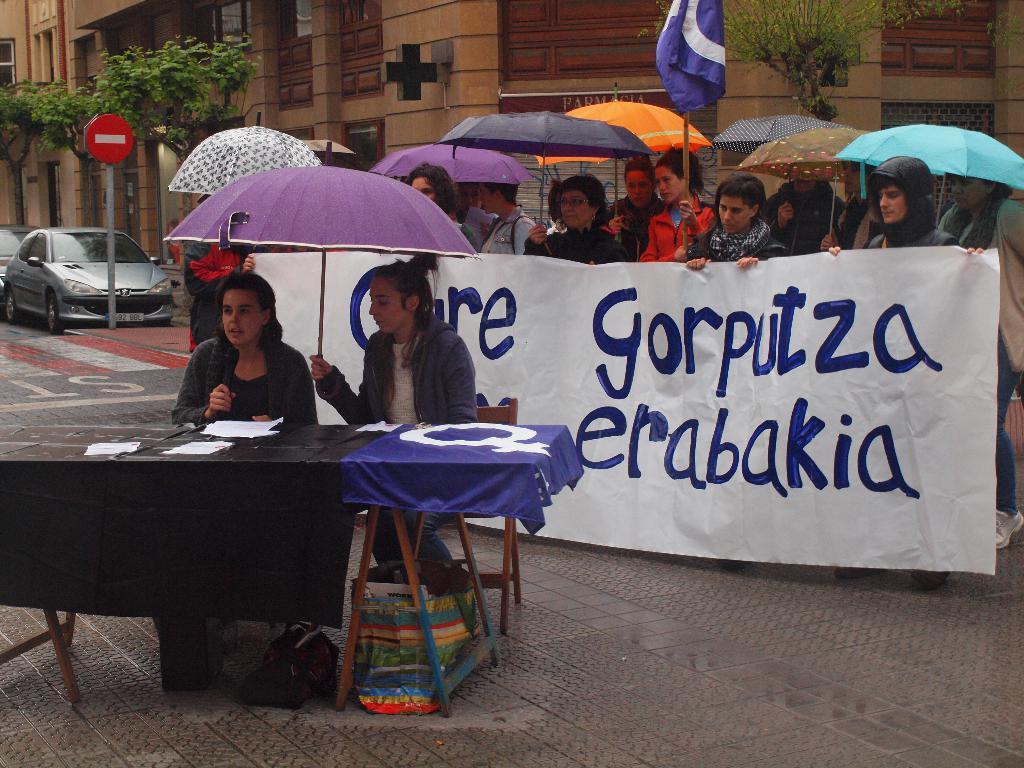How would you summarize this image in a sentence or two? In this image i can see 2 women sitting in front of a table and i can see few papers on the table, one of the woman is holding umbrella in her hand. In the background i can see few people standing with umbrellas in their hands,a flag, a building, a sign, few vehicles and some trees. 